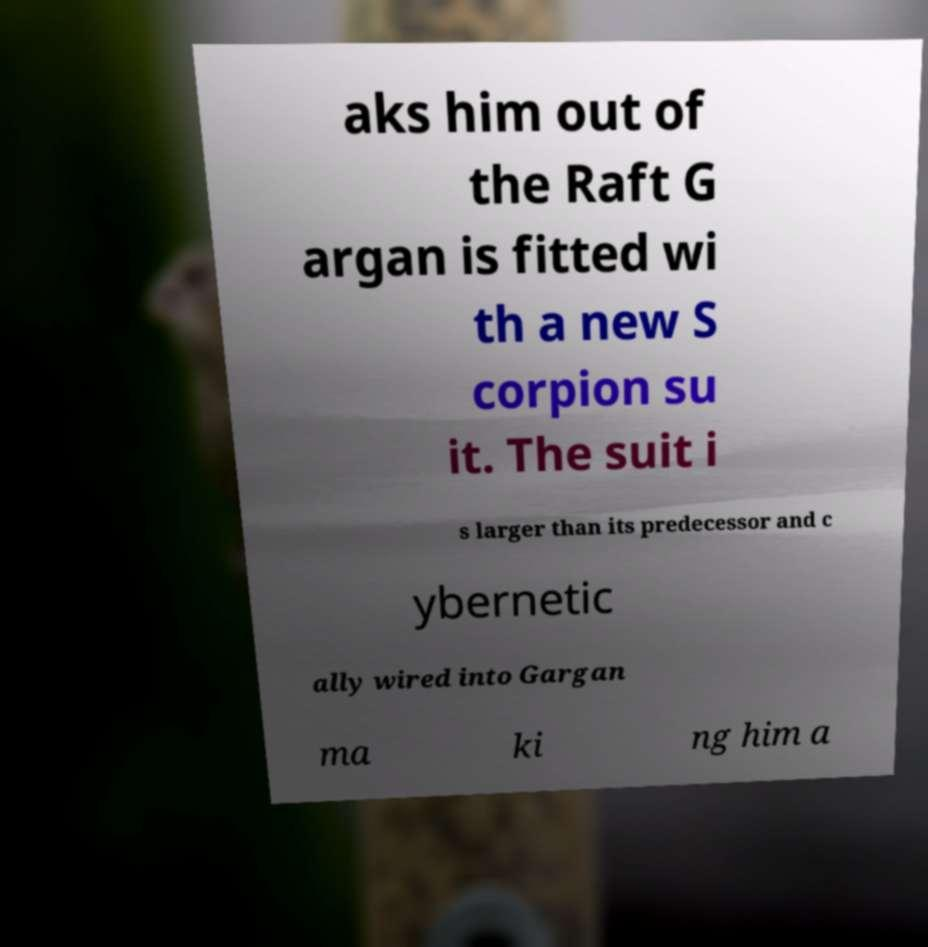There's text embedded in this image that I need extracted. Can you transcribe it verbatim? aks him out of the Raft G argan is fitted wi th a new S corpion su it. The suit i s larger than its predecessor and c ybernetic ally wired into Gargan ma ki ng him a 